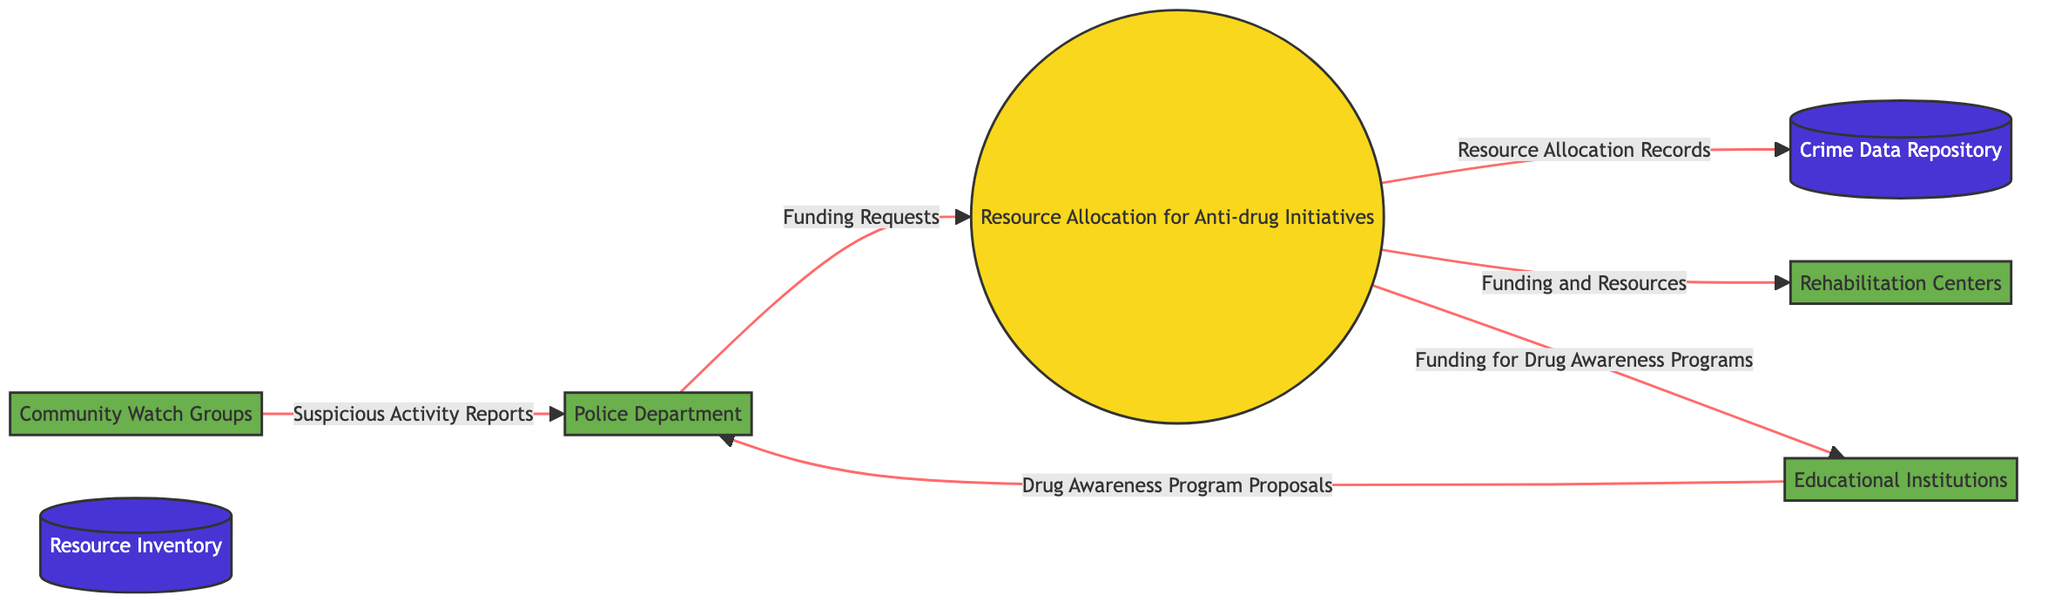What is the main process identified in the diagram? The main process identified is "Resource Allocation for Anti-drug Initiatives," which appears at the center of the diagram.
Answer: Resource Allocation for Anti-drug Initiatives How many external entities are represented in the diagram? There are four external entities listed: Police Department, Community Watch Groups, Rehabilitation Centers, and Educational Institutions. Adding these entities gives a total of four.
Answer: 4 Which entity provides "Funding Requests" to the main process? The Police Department is the entity that sends "Funding Requests" to the main process, as indicated by the arrow connecting the two.
Answer: Police Department What type of data flows from the "Resource Allocation for Anti-drug Initiatives" to the "Crime Data Repository"? The data flowing from the main process to the Crime Data Repository is described as "Resource Allocation Records." This indicates records are maintained in the repository regarding resource distribution.
Answer: Resource Allocation Records Which external entity receives "Funding for Drug Awareness Programs"? The external entity that receives "Funding for Drug Awareness Programs" from the main process is the Educational Institutions, as indicated by the direct flow to this entity.
Answer: Educational Institutions What does the "Community Watch Groups" send to the "Police Department"? The "Community Watch Groups" send "Suspicious Activity Reports" to the "Police Department," as shown by the connection between these two entities.
Answer: Suspicious Activity Reports Which two entities are involved in drug awareness initiatives? The Educational Institutions and the Police Department are involved in drug awareness initiatives as they exchange "Drug Awareness Program Proposals" and receive funding for educational programs.
Answer: Educational Institutions and Police Department What is stored in the "Crime Data Repository"? The "Crime Data Repository" stores records labeled as "Resource Allocation Records," indicating it keeps track of the resources allocated to various anti-drug initiatives.
Answer: Resource Allocation Records How many types of data stores are present in the diagram? There are two types of data stores identified in the diagram: "Crime Data Repository" and "Resource Inventory."
Answer: 2 